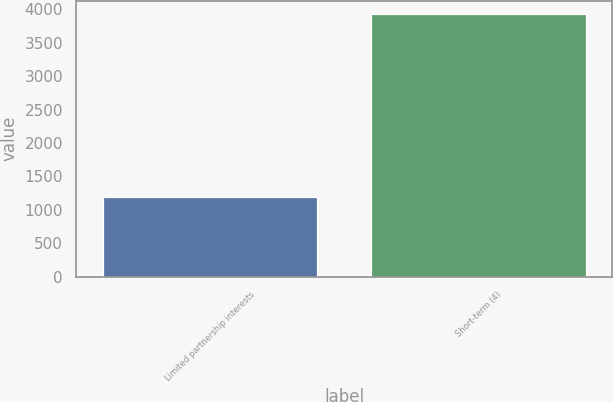Convert chart. <chart><loc_0><loc_0><loc_500><loc_500><bar_chart><fcel>Limited partnership interests<fcel>Short-term (4)<nl><fcel>1191<fcel>3930<nl></chart> 